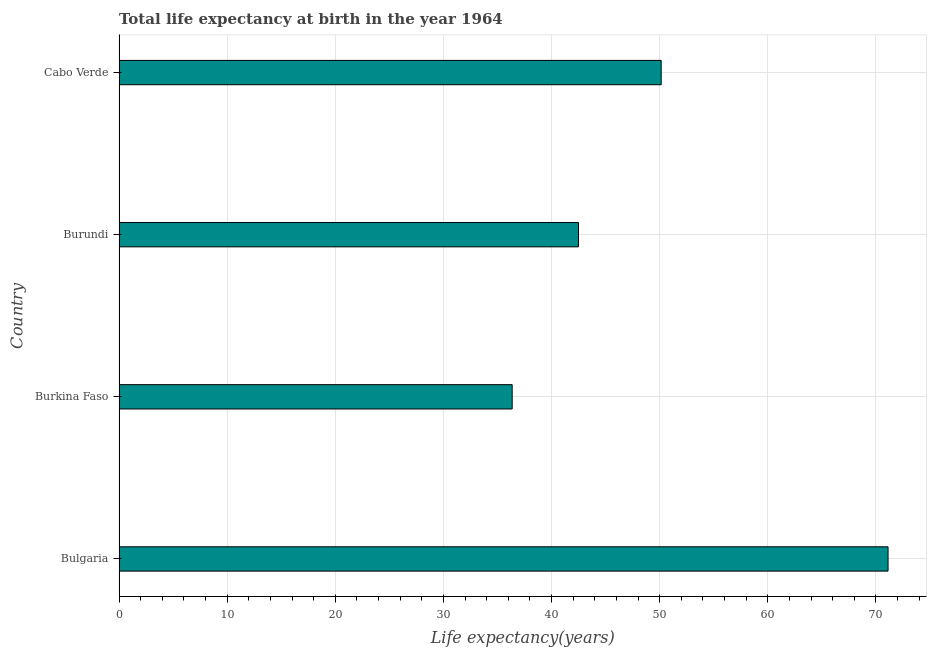What is the title of the graph?
Keep it short and to the point. Total life expectancy at birth in the year 1964. What is the label or title of the X-axis?
Make the answer very short. Life expectancy(years). What is the label or title of the Y-axis?
Make the answer very short. Country. What is the life expectancy at birth in Burundi?
Offer a terse response. 42.49. Across all countries, what is the maximum life expectancy at birth?
Make the answer very short. 71.12. Across all countries, what is the minimum life expectancy at birth?
Make the answer very short. 36.36. In which country was the life expectancy at birth maximum?
Give a very brief answer. Bulgaria. In which country was the life expectancy at birth minimum?
Your answer should be very brief. Burkina Faso. What is the sum of the life expectancy at birth?
Give a very brief answer. 200.11. What is the difference between the life expectancy at birth in Bulgaria and Cabo Verde?
Keep it short and to the point. 20.98. What is the average life expectancy at birth per country?
Offer a very short reply. 50.03. What is the median life expectancy at birth?
Your answer should be very brief. 46.32. What is the ratio of the life expectancy at birth in Bulgaria to that in Cabo Verde?
Give a very brief answer. 1.42. Is the life expectancy at birth in Burkina Faso less than that in Cabo Verde?
Make the answer very short. Yes. What is the difference between the highest and the second highest life expectancy at birth?
Provide a short and direct response. 20.98. What is the difference between the highest and the lowest life expectancy at birth?
Offer a terse response. 34.76. In how many countries, is the life expectancy at birth greater than the average life expectancy at birth taken over all countries?
Ensure brevity in your answer.  2. How many countries are there in the graph?
Your answer should be compact. 4. What is the difference between two consecutive major ticks on the X-axis?
Ensure brevity in your answer.  10. What is the Life expectancy(years) in Bulgaria?
Offer a terse response. 71.12. What is the Life expectancy(years) of Burkina Faso?
Provide a short and direct response. 36.36. What is the Life expectancy(years) in Burundi?
Make the answer very short. 42.49. What is the Life expectancy(years) of Cabo Verde?
Provide a short and direct response. 50.14. What is the difference between the Life expectancy(years) in Bulgaria and Burkina Faso?
Make the answer very short. 34.76. What is the difference between the Life expectancy(years) in Bulgaria and Burundi?
Your answer should be compact. 28.63. What is the difference between the Life expectancy(years) in Bulgaria and Cabo Verde?
Offer a very short reply. 20.98. What is the difference between the Life expectancy(years) in Burkina Faso and Burundi?
Your answer should be very brief. -6.13. What is the difference between the Life expectancy(years) in Burkina Faso and Cabo Verde?
Keep it short and to the point. -13.78. What is the difference between the Life expectancy(years) in Burundi and Cabo Verde?
Your response must be concise. -7.65. What is the ratio of the Life expectancy(years) in Bulgaria to that in Burkina Faso?
Provide a succinct answer. 1.96. What is the ratio of the Life expectancy(years) in Bulgaria to that in Burundi?
Keep it short and to the point. 1.67. What is the ratio of the Life expectancy(years) in Bulgaria to that in Cabo Verde?
Offer a very short reply. 1.42. What is the ratio of the Life expectancy(years) in Burkina Faso to that in Burundi?
Your answer should be compact. 0.86. What is the ratio of the Life expectancy(years) in Burkina Faso to that in Cabo Verde?
Your answer should be compact. 0.72. What is the ratio of the Life expectancy(years) in Burundi to that in Cabo Verde?
Your answer should be very brief. 0.85. 